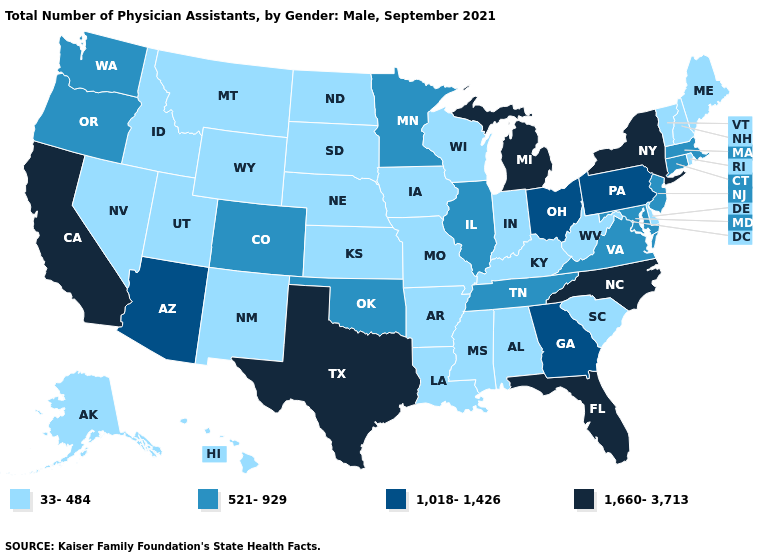Which states hav the highest value in the Northeast?
Short answer required. New York. What is the value of Texas?
Quick response, please. 1,660-3,713. Does Florida have the highest value in the USA?
Answer briefly. Yes. What is the value of Utah?
Quick response, please. 33-484. Does Iowa have a lower value than West Virginia?
Be succinct. No. Is the legend a continuous bar?
Be succinct. No. Name the states that have a value in the range 1,018-1,426?
Concise answer only. Arizona, Georgia, Ohio, Pennsylvania. Which states hav the highest value in the South?
Write a very short answer. Florida, North Carolina, Texas. Among the states that border Connecticut , which have the highest value?
Short answer required. New York. What is the lowest value in states that border Texas?
Short answer required. 33-484. What is the highest value in states that border Vermont?
Concise answer only. 1,660-3,713. What is the lowest value in the USA?
Concise answer only. 33-484. Does Kansas have the lowest value in the USA?
Answer briefly. Yes. Among the states that border Florida , which have the highest value?
Concise answer only. Georgia. Name the states that have a value in the range 521-929?
Quick response, please. Colorado, Connecticut, Illinois, Maryland, Massachusetts, Minnesota, New Jersey, Oklahoma, Oregon, Tennessee, Virginia, Washington. 